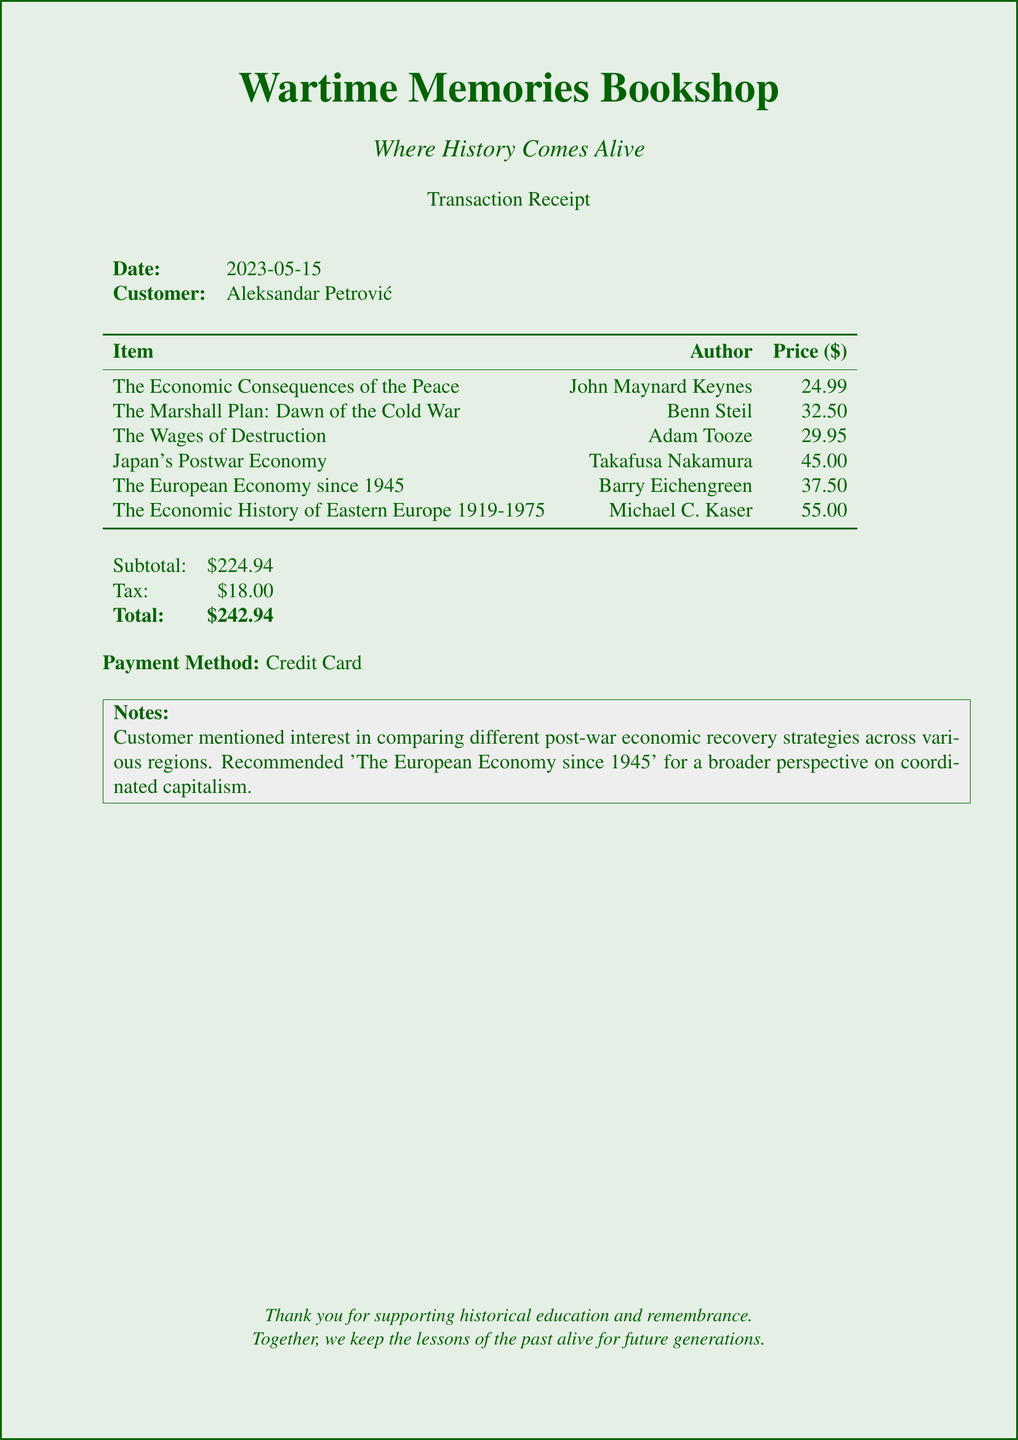What is the store name? The store name is prominently displayed at the top of the document.
Answer: Wartime Memories Bookshop What is the date of the transaction? The date is listed in the transaction details section of the document.
Answer: 2023-05-15 Who is the customer? The customer's name is noted in the transaction details.
Answer: Aleksandar Petrović What is the price of "The Wages of Destruction"? The price for each item is listed alongside its title and author.
Answer: 29.95 What is the subtotal amount? The subtotal is clearly labeled towards the end of the document.
Answer: 224.94 Which payment method was used? The payment method is specified in the transaction details.
Answer: Credit Card How many books were purchased? The number of items listed in the document indicates how many books were bought.
Answer: 6 What is the tax amount? The tax amount is detailed in the financial summary section of the document.
Answer: 18.00 What note was made by the customer? The notes section provides insight into the customer's interests and recommendations.
Answer: Comparing different post-war economic recovery strategies across various regions 